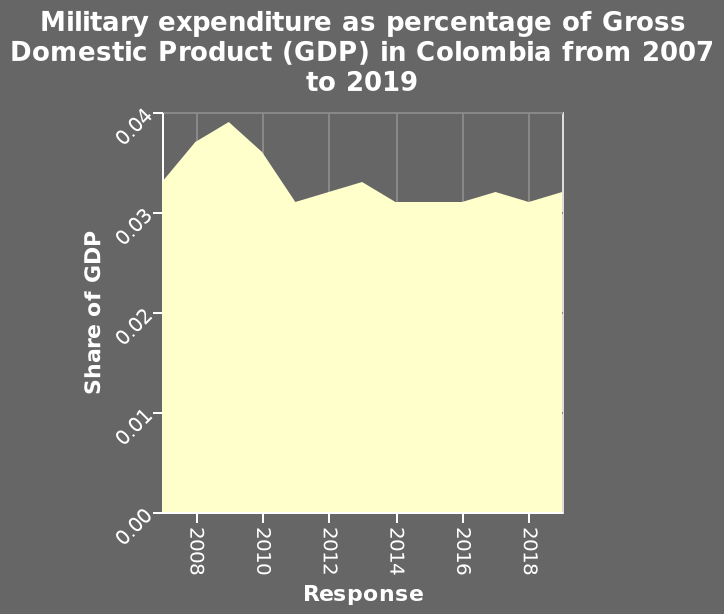<image>
please summary the statistics and relations of the chart There is a high point in 2009 then from2010 there is very little variation. Is there any significant change in the data after 2010? No, there is very little variation in the data after 2010. 